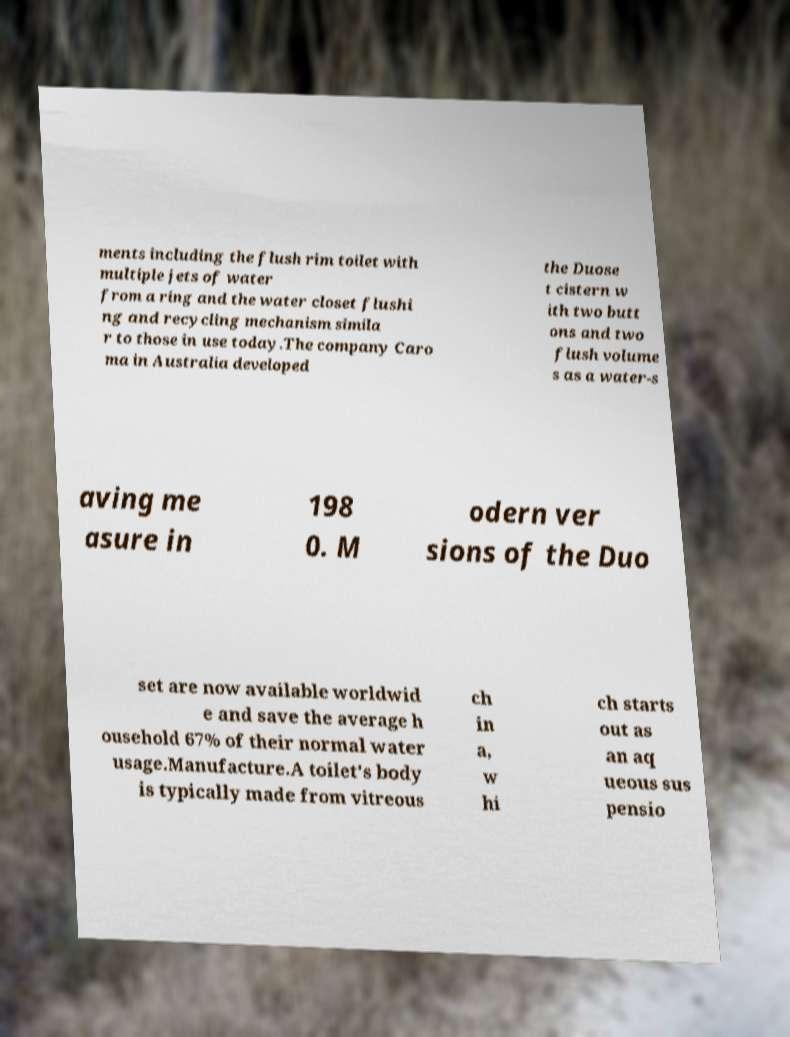For documentation purposes, I need the text within this image transcribed. Could you provide that? ments including the flush rim toilet with multiple jets of water from a ring and the water closet flushi ng and recycling mechanism simila r to those in use today.The company Caro ma in Australia developed the Duose t cistern w ith two butt ons and two flush volume s as a water-s aving me asure in 198 0. M odern ver sions of the Duo set are now available worldwid e and save the average h ousehold 67% of their normal water usage.Manufacture.A toilet's body is typically made from vitreous ch in a, w hi ch starts out as an aq ueous sus pensio 